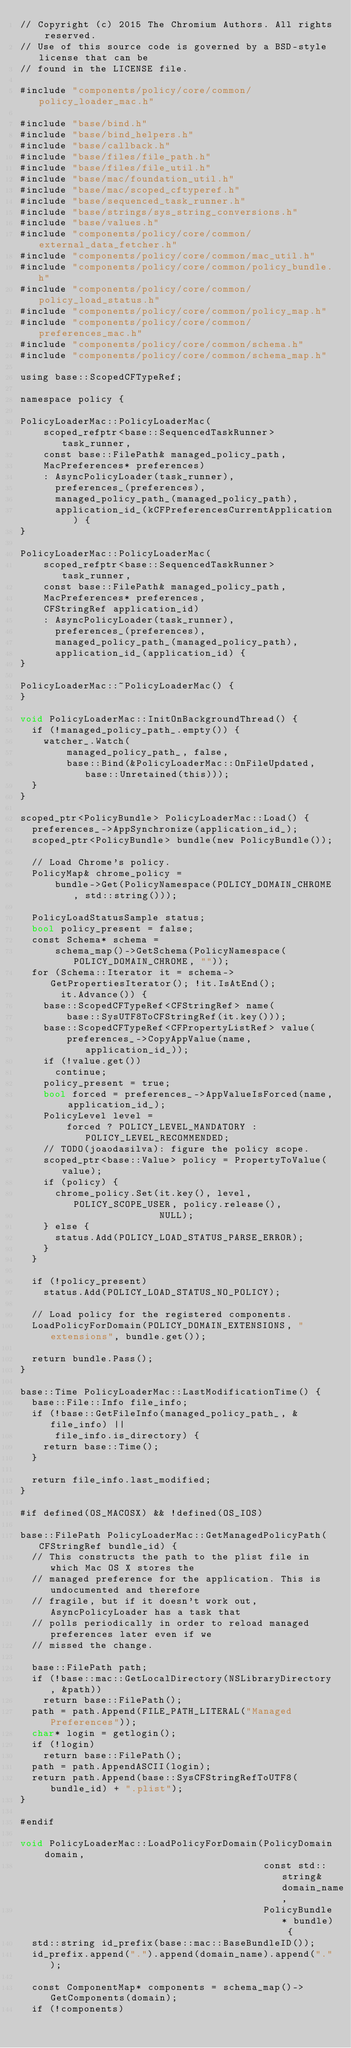<code> <loc_0><loc_0><loc_500><loc_500><_ObjectiveC_>// Copyright (c) 2015 The Chromium Authors. All rights reserved.
// Use of this source code is governed by a BSD-style license that can be
// found in the LICENSE file.

#include "components/policy/core/common/policy_loader_mac.h"

#include "base/bind.h"
#include "base/bind_helpers.h"
#include "base/callback.h"
#include "base/files/file_path.h"
#include "base/files/file_util.h"
#include "base/mac/foundation_util.h"
#include "base/mac/scoped_cftyperef.h"
#include "base/sequenced_task_runner.h"
#include "base/strings/sys_string_conversions.h"
#include "base/values.h"
#include "components/policy/core/common/external_data_fetcher.h"
#include "components/policy/core/common/mac_util.h"
#include "components/policy/core/common/policy_bundle.h"
#include "components/policy/core/common/policy_load_status.h"
#include "components/policy/core/common/policy_map.h"
#include "components/policy/core/common/preferences_mac.h"
#include "components/policy/core/common/schema.h"
#include "components/policy/core/common/schema_map.h"

using base::ScopedCFTypeRef;

namespace policy {

PolicyLoaderMac::PolicyLoaderMac(
    scoped_refptr<base::SequencedTaskRunner> task_runner,
    const base::FilePath& managed_policy_path,
    MacPreferences* preferences)
    : AsyncPolicyLoader(task_runner),
      preferences_(preferences),
      managed_policy_path_(managed_policy_path),
      application_id_(kCFPreferencesCurrentApplication) {
}

PolicyLoaderMac::PolicyLoaderMac(
    scoped_refptr<base::SequencedTaskRunner> task_runner,
    const base::FilePath& managed_policy_path,
    MacPreferences* preferences,
    CFStringRef application_id)
    : AsyncPolicyLoader(task_runner),
      preferences_(preferences),
      managed_policy_path_(managed_policy_path),
      application_id_(application_id) {
}

PolicyLoaderMac::~PolicyLoaderMac() {
}

void PolicyLoaderMac::InitOnBackgroundThread() {
  if (!managed_policy_path_.empty()) {
    watcher_.Watch(
        managed_policy_path_, false,
        base::Bind(&PolicyLoaderMac::OnFileUpdated, base::Unretained(this)));
  }
}

scoped_ptr<PolicyBundle> PolicyLoaderMac::Load() {
  preferences_->AppSynchronize(application_id_);
  scoped_ptr<PolicyBundle> bundle(new PolicyBundle());

  // Load Chrome's policy.
  PolicyMap& chrome_policy =
      bundle->Get(PolicyNamespace(POLICY_DOMAIN_CHROME, std::string()));

  PolicyLoadStatusSample status;
  bool policy_present = false;
  const Schema* schema =
      schema_map()->GetSchema(PolicyNamespace(POLICY_DOMAIN_CHROME, ""));
  for (Schema::Iterator it = schema->GetPropertiesIterator(); !it.IsAtEnd();
       it.Advance()) {
    base::ScopedCFTypeRef<CFStringRef> name(
        base::SysUTF8ToCFStringRef(it.key()));
    base::ScopedCFTypeRef<CFPropertyListRef> value(
        preferences_->CopyAppValue(name, application_id_));
    if (!value.get())
      continue;
    policy_present = true;
    bool forced = preferences_->AppValueIsForced(name, application_id_);
    PolicyLevel level =
        forced ? POLICY_LEVEL_MANDATORY : POLICY_LEVEL_RECOMMENDED;
    // TODO(joaodasilva): figure the policy scope.
    scoped_ptr<base::Value> policy = PropertyToValue(value);
    if (policy) {
      chrome_policy.Set(it.key(), level, POLICY_SCOPE_USER, policy.release(),
                        NULL);
    } else {
      status.Add(POLICY_LOAD_STATUS_PARSE_ERROR);
    }
  }

  if (!policy_present)
    status.Add(POLICY_LOAD_STATUS_NO_POLICY);

  // Load policy for the registered components.
  LoadPolicyForDomain(POLICY_DOMAIN_EXTENSIONS, "extensions", bundle.get());

  return bundle.Pass();
}

base::Time PolicyLoaderMac::LastModificationTime() {
  base::File::Info file_info;
  if (!base::GetFileInfo(managed_policy_path_, &file_info) ||
      file_info.is_directory) {
    return base::Time();
  }

  return file_info.last_modified;
}

#if defined(OS_MACOSX) && !defined(OS_IOS)

base::FilePath PolicyLoaderMac::GetManagedPolicyPath(CFStringRef bundle_id) {
  // This constructs the path to the plist file in which Mac OS X stores the
  // managed preference for the application. This is undocumented and therefore
  // fragile, but if it doesn't work out, AsyncPolicyLoader has a task that
  // polls periodically in order to reload managed preferences later even if we
  // missed the change.

  base::FilePath path;
  if (!base::mac::GetLocalDirectory(NSLibraryDirectory, &path))
    return base::FilePath();
  path = path.Append(FILE_PATH_LITERAL("Managed Preferences"));
  char* login = getlogin();
  if (!login)
    return base::FilePath();
  path = path.AppendASCII(login);
  return path.Append(base::SysCFStringRefToUTF8(bundle_id) + ".plist");
}

#endif

void PolicyLoaderMac::LoadPolicyForDomain(PolicyDomain domain,
                                          const std::string& domain_name,
                                          PolicyBundle* bundle) {
  std::string id_prefix(base::mac::BaseBundleID());
  id_prefix.append(".").append(domain_name).append(".");

  const ComponentMap* components = schema_map()->GetComponents(domain);
  if (!components)</code> 